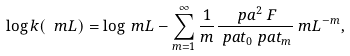Convert formula to latex. <formula><loc_0><loc_0><loc_500><loc_500>\log k ( \ m L ) & = \log \ m L - \sum _ { m = 1 } ^ { \infty } \frac { 1 } { m } \frac { \ p a ^ { 2 } \ F } { \ p a t _ { 0 } \ p a t _ { m } } \ m L ^ { - m } ,</formula> 